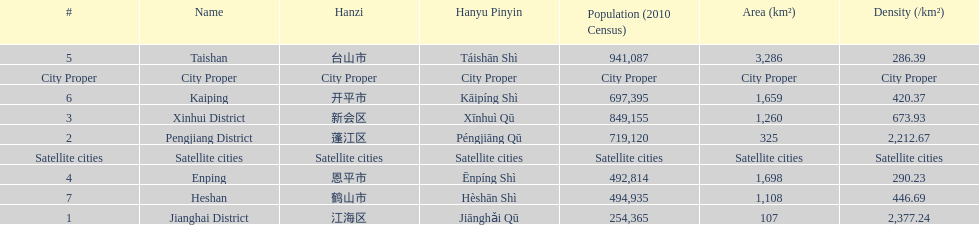Which area under the satellite cities has the most in population? Taishan. 